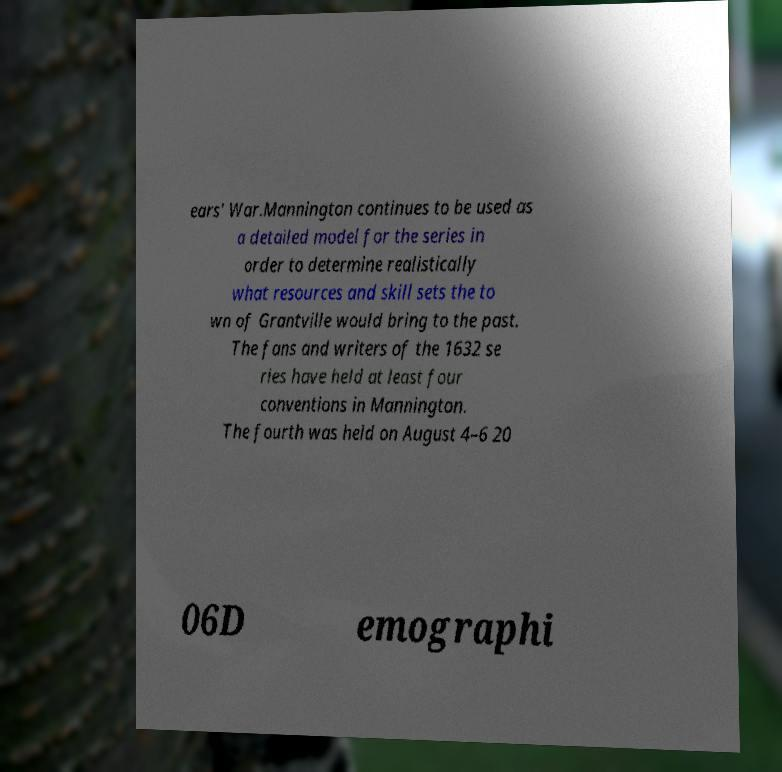Can you accurately transcribe the text from the provided image for me? ears' War.Mannington continues to be used as a detailed model for the series in order to determine realistically what resources and skill sets the to wn of Grantville would bring to the past. The fans and writers of the 1632 se ries have held at least four conventions in Mannington. The fourth was held on August 4–6 20 06D emographi 